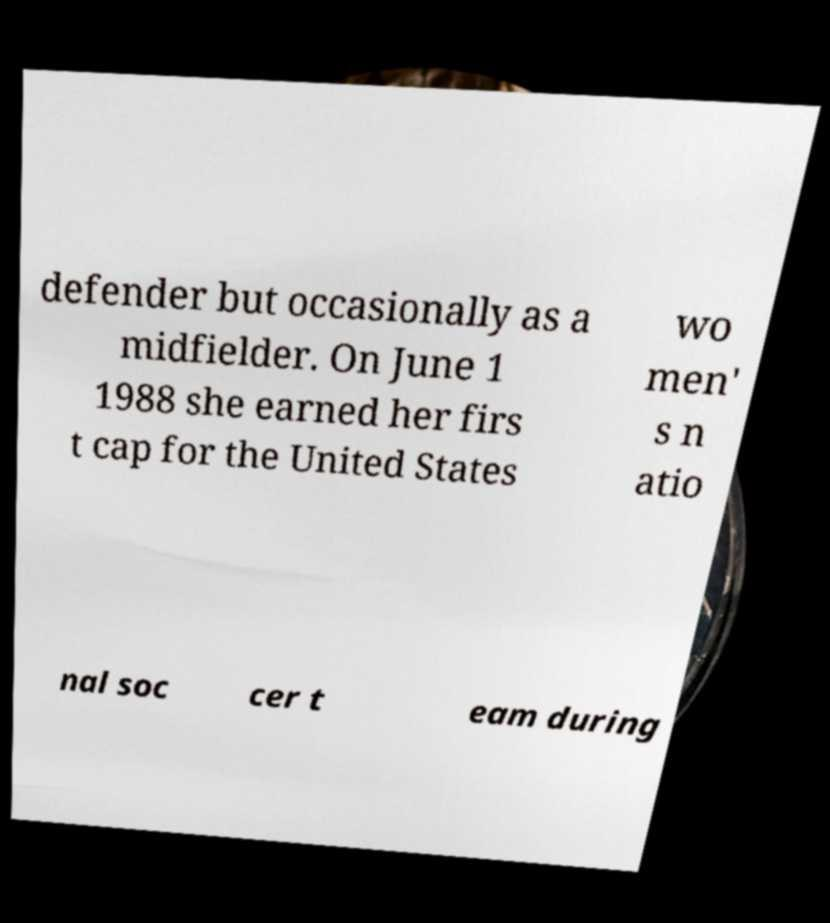Can you read and provide the text displayed in the image?This photo seems to have some interesting text. Can you extract and type it out for me? defender but occasionally as a midfielder. On June 1 1988 she earned her firs t cap for the United States wo men' s n atio nal soc cer t eam during 